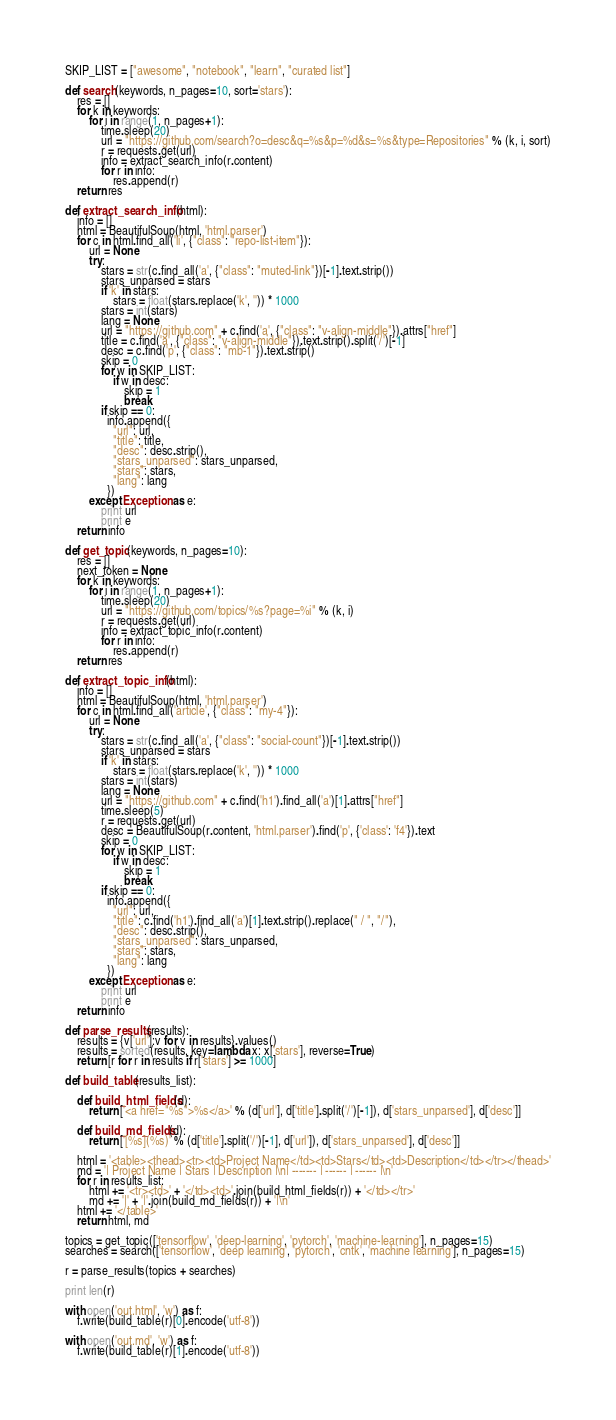Convert code to text. <code><loc_0><loc_0><loc_500><loc_500><_Python_>
SKIP_LIST = ["awesome", "notebook", "learn", "curated list"]

def search(keywords, n_pages=10, sort='stars'):
    res = []
    for k in keywords:
        for i in range(1, n_pages+1):
            time.sleep(20)
            url = "https://github.com/search?o=desc&q=%s&p=%d&s=%s&type=Repositories" % (k, i, sort)
            r = requests.get(url)
            info = extract_search_info(r.content)
            for r in info:
                res.append(r)
    return res

def extract_search_info(html):
    info = []
    html = BeautifulSoup(html, 'html.parser')
    for c in html.find_all('li', {"class": "repo-list-item"}):
        url = None
        try:
            stars = str(c.find_all('a', {"class": "muted-link"})[-1].text.strip())
            stars_unparsed = stars
            if 'k' in stars:
                stars = float(stars.replace('k', '')) * 1000
            stars = int(stars)
            lang = None
            url = "https://github.com" + c.find('a', {"class": "v-align-middle"}).attrs["href"]
            title = c.find('a', {"class": "v-align-middle"}).text.strip().split('/')[-1]
            desc = c.find('p', {"class": "mb-1"}).text.strip()
            skip = 0
            for w in SKIP_LIST:
                if w in desc:
                    skip = 1
                    break
            if skip == 0:
              info.append({
                "url": url,
                "title": title,
                "desc": desc.strip(),
                "stars_unparsed": stars_unparsed,
                "stars": stars,
                "lang": lang
              })
        except Exception as e:
            print url
            print e
    return info

def get_topic(keywords, n_pages=10):
    res = []
    next_token = None
    for k in keywords:
        for i in range(1, n_pages+1):
            time.sleep(20)
            url = "https://github.com/topics/%s?page=%i" % (k, i)
            r = requests.get(url)
            info = extract_topic_info(r.content)
            for r in info:
                res.append(r)
    return res

def extract_topic_info(html):
    info = []
    html = BeautifulSoup(html, 'html.parser')
    for c in html.find_all('article', {"class": "my-4"}):
        url = None
        try:
            stars = str(c.find_all('a', {"class": "social-count"})[-1].text.strip())
            stars_unparsed = stars
            if 'k' in stars:
                stars = float(stars.replace('k', '')) * 1000
            stars = int(stars)
            lang = None
            url = "https://github.com" + c.find('h1').find_all('a')[1].attrs["href"]
            time.sleep(5)
            r = requests.get(url)
            desc = BeautifulSoup(r.content, 'html.parser').find('p', {'class': 'f4'}).text
            skip = 0
            for w in SKIP_LIST:
                if w in desc:
                    skip = 1
                    break
            if skip == 0:
              info.append({
                "url": url,
                "title": c.find('h1').find_all('a')[1].text.strip().replace(" / ", "/"),
                "desc": desc.strip(),
                "stars_unparsed": stars_unparsed,
                "stars": stars,
                "lang": lang
              })
        except Exception as e:
            print url
            print e
    return info

def parse_results(results):
    results = {v['url']:v for v in results}.values()
    results = sorted(results, key=lambda x: x['stars'], reverse=True)
    return [r for r in results if r['stars'] >= 1000]

def build_table(results_list):

    def build_html_fields(d):
        return ['<a href="%s">%s</a>' % (d['url'], d['title'].split('/')[-1]), d['stars_unparsed'], d['desc']]

    def build_md_fields(d):
        return ['[%s](%s)' % (d['title'].split('/')[-1], d['url']), d['stars_unparsed'], d['desc']]

    html = '<table><thead><tr><td>Project Name</td><td>Stars</td><td>Description</td></tr></thead>'
    md = '| Project Name | Stars | Description |\n| ------- | ------ | ------ |\n'
    for r in results_list:
        html += '<tr><td>' + '</td><td>'.join(build_html_fields(r)) + '</td></tr>'
        md += '|' + '|'.join(build_md_fields(r)) + '|\n'
    html += '</table>'
    return html, md

topics = get_topic(['tensorflow', 'deep-learning', 'pytorch', 'machine-learning'], n_pages=15)
searches = search(['tensorflow', 'deep learning', 'pytorch', 'cntk', 'machine learning'], n_pages=15)

r = parse_results(topics + searches)

print len(r)

with open('out.html', 'w') as f:
    f.write(build_table(r)[0].encode('utf-8'))

with open('out.md', 'w') as f:
    f.write(build_table(r)[1].encode('utf-8'))
</code> 